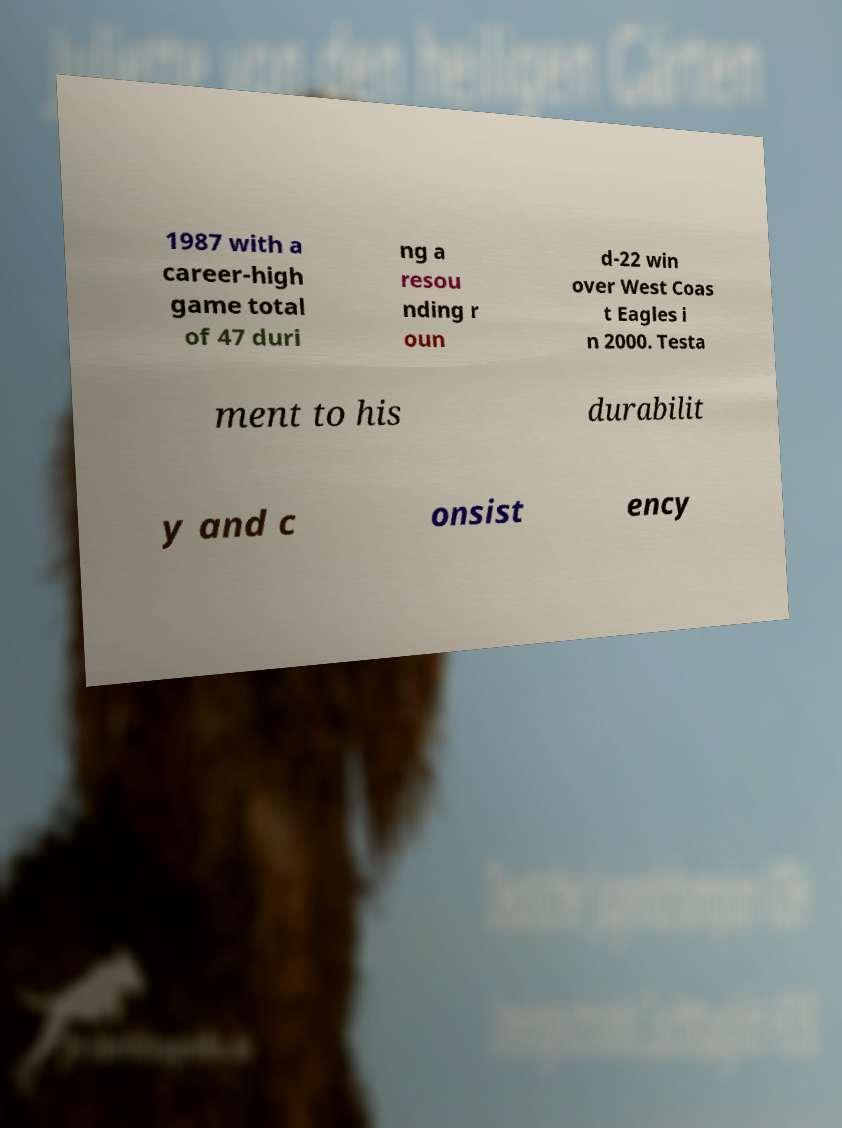For documentation purposes, I need the text within this image transcribed. Could you provide that? 1987 with a career-high game total of 47 duri ng a resou nding r oun d-22 win over West Coas t Eagles i n 2000. Testa ment to his durabilit y and c onsist ency 